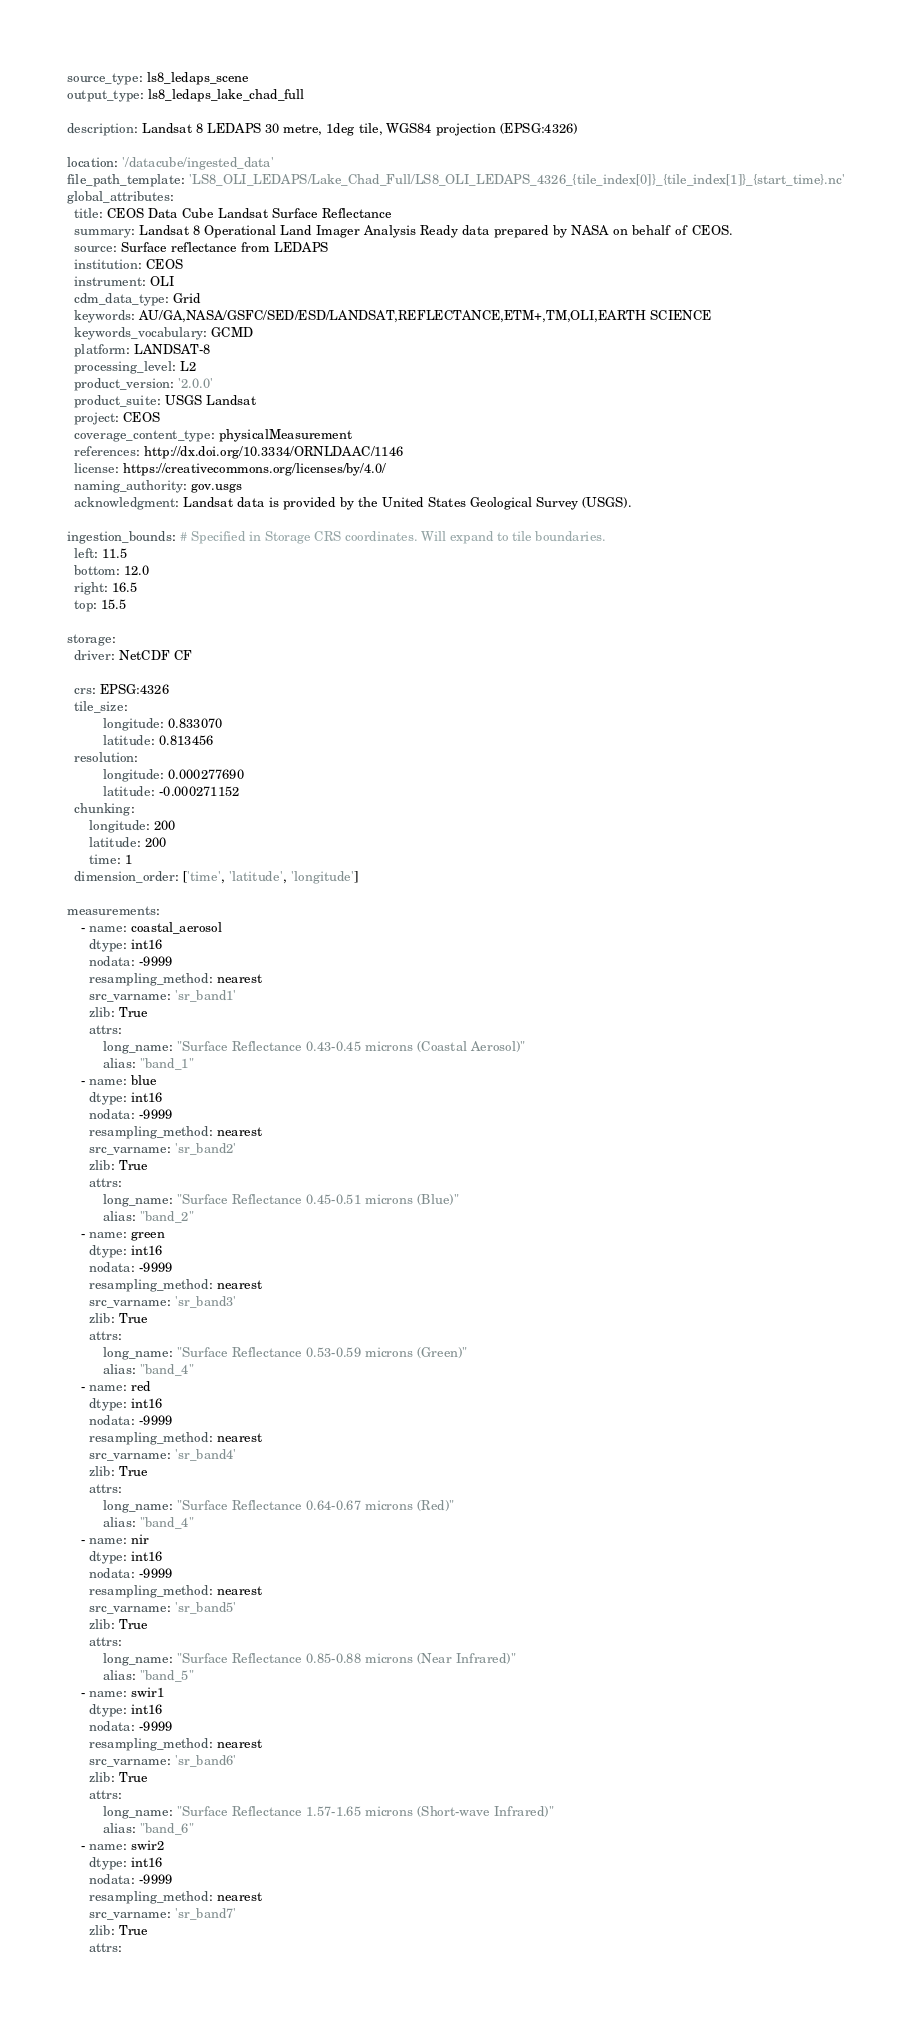<code> <loc_0><loc_0><loc_500><loc_500><_YAML_>source_type: ls8_ledaps_scene
output_type: ls8_ledaps_lake_chad_full

description: Landsat 8 LEDAPS 30 metre, 1deg tile, WGS84 projection (EPSG:4326)

location: '/datacube/ingested_data'
file_path_template: 'LS8_OLI_LEDAPS/Lake_Chad_Full/LS8_OLI_LEDAPS_4326_{tile_index[0]}_{tile_index[1]}_{start_time}.nc'
global_attributes:
  title: CEOS Data Cube Landsat Surface Reflectance
  summary: Landsat 8 Operational Land Imager Analysis Ready data prepared by NASA on behalf of CEOS.
  source: Surface reflectance from LEDAPS
  institution: CEOS
  instrument: OLI
  cdm_data_type: Grid
  keywords: AU/GA,NASA/GSFC/SED/ESD/LANDSAT,REFLECTANCE,ETM+,TM,OLI,EARTH SCIENCE
  keywords_vocabulary: GCMD
  platform: LANDSAT-8
  processing_level: L2
  product_version: '2.0.0'
  product_suite: USGS Landsat
  project: CEOS
  coverage_content_type: physicalMeasurement
  references: http://dx.doi.org/10.3334/ORNLDAAC/1146
  license: https://creativecommons.org/licenses/by/4.0/
  naming_authority: gov.usgs
  acknowledgment: Landsat data is provided by the United States Geological Survey (USGS).

ingestion_bounds: # Specified in Storage CRS coordinates. Will expand to tile boundaries.
  left: 11.5
  bottom: 12.0
  right: 16.5
  top: 15.5

storage:
  driver: NetCDF CF

  crs: EPSG:4326
  tile_size:
          longitude: 0.833070
          latitude: 0.813456
  resolution:
          longitude: 0.000277690
          latitude: -0.000271152
  chunking:
      longitude: 200
      latitude: 200
      time: 1
  dimension_order: ['time', 'latitude', 'longitude']

measurements:
    - name: coastal_aerosol
      dtype: int16
      nodata: -9999
      resampling_method: nearest
      src_varname: 'sr_band1'
      zlib: True
      attrs:
          long_name: "Surface Reflectance 0.43-0.45 microns (Coastal Aerosol)"
          alias: "band_1"
    - name: blue
      dtype: int16
      nodata: -9999
      resampling_method: nearest
      src_varname: 'sr_band2'
      zlib: True
      attrs:
          long_name: "Surface Reflectance 0.45-0.51 microns (Blue)"
          alias: "band_2"
    - name: green
      dtype: int16
      nodata: -9999
      resampling_method: nearest
      src_varname: 'sr_band3'
      zlib: True
      attrs:
          long_name: "Surface Reflectance 0.53-0.59 microns (Green)"
          alias: "band_4"
    - name: red
      dtype: int16
      nodata: -9999
      resampling_method: nearest
      src_varname: 'sr_band4'
      zlib: True
      attrs:
          long_name: "Surface Reflectance 0.64-0.67 microns (Red)"
          alias: "band_4"
    - name: nir
      dtype: int16
      nodata: -9999
      resampling_method: nearest
      src_varname: 'sr_band5'
      zlib: True
      attrs:
          long_name: "Surface Reflectance 0.85-0.88 microns (Near Infrared)"
          alias: "band_5"
    - name: swir1
      dtype: int16
      nodata: -9999
      resampling_method: nearest
      src_varname: 'sr_band6'
      zlib: True
      attrs:
          long_name: "Surface Reflectance 1.57-1.65 microns (Short-wave Infrared)"
          alias: "band_6"
    - name: swir2
      dtype: int16
      nodata: -9999
      resampling_method: nearest
      src_varname: 'sr_band7'
      zlib: True
      attrs:</code> 